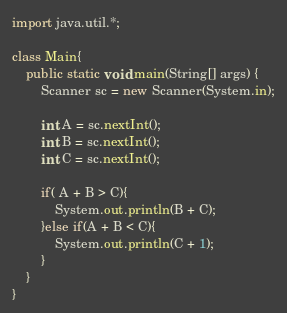Convert code to text. <code><loc_0><loc_0><loc_500><loc_500><_Java_>import java.util.*;

class Main{
    public static void main(String[] args) {
        Scanner sc = new Scanner(System.in);

        int A = sc.nextInt();
        int B = sc.nextInt();
        int C = sc.nextInt();

        if( A + B > C){
            System.out.println(B + C);
        }else if(A + B < C){
            System.out.println(C + 1);
        }
    }
}</code> 